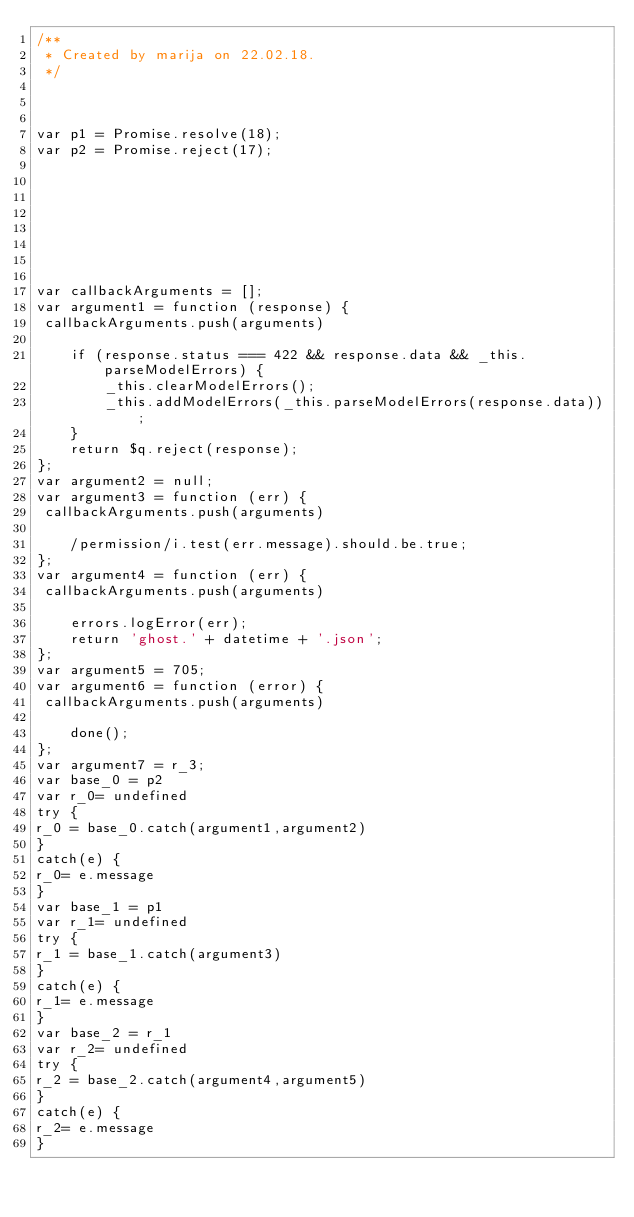<code> <loc_0><loc_0><loc_500><loc_500><_JavaScript_>/**
 * Created by marija on 22.02.18.
 */



var p1 = Promise.resolve(18);
var p2 = Promise.reject(17);








var callbackArguments = [];
var argument1 = function (response) {
 callbackArguments.push(arguments) 

    if (response.status === 422 && response.data && _this.parseModelErrors) {
        _this.clearModelErrors();
        _this.addModelErrors(_this.parseModelErrors(response.data));
    }
    return $q.reject(response);
};
var argument2 = null;
var argument3 = function (err) {
 callbackArguments.push(arguments) 

    /permission/i.test(err.message).should.be.true;
};
var argument4 = function (err) {
 callbackArguments.push(arguments) 

    errors.logError(err);
    return 'ghost.' + datetime + '.json';
};
var argument5 = 705;
var argument6 = function (error) {
 callbackArguments.push(arguments) 

    done();
};
var argument7 = r_3;
var base_0 = p2
var r_0= undefined
try {
r_0 = base_0.catch(argument1,argument2)
}
catch(e) {
r_0= e.message
}
var base_1 = p1
var r_1= undefined
try {
r_1 = base_1.catch(argument3)
}
catch(e) {
r_1= e.message
}
var base_2 = r_1
var r_2= undefined
try {
r_2 = base_2.catch(argument4,argument5)
}
catch(e) {
r_2= e.message
}</code> 